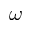Convert formula to latex. <formula><loc_0><loc_0><loc_500><loc_500>\omega</formula> 